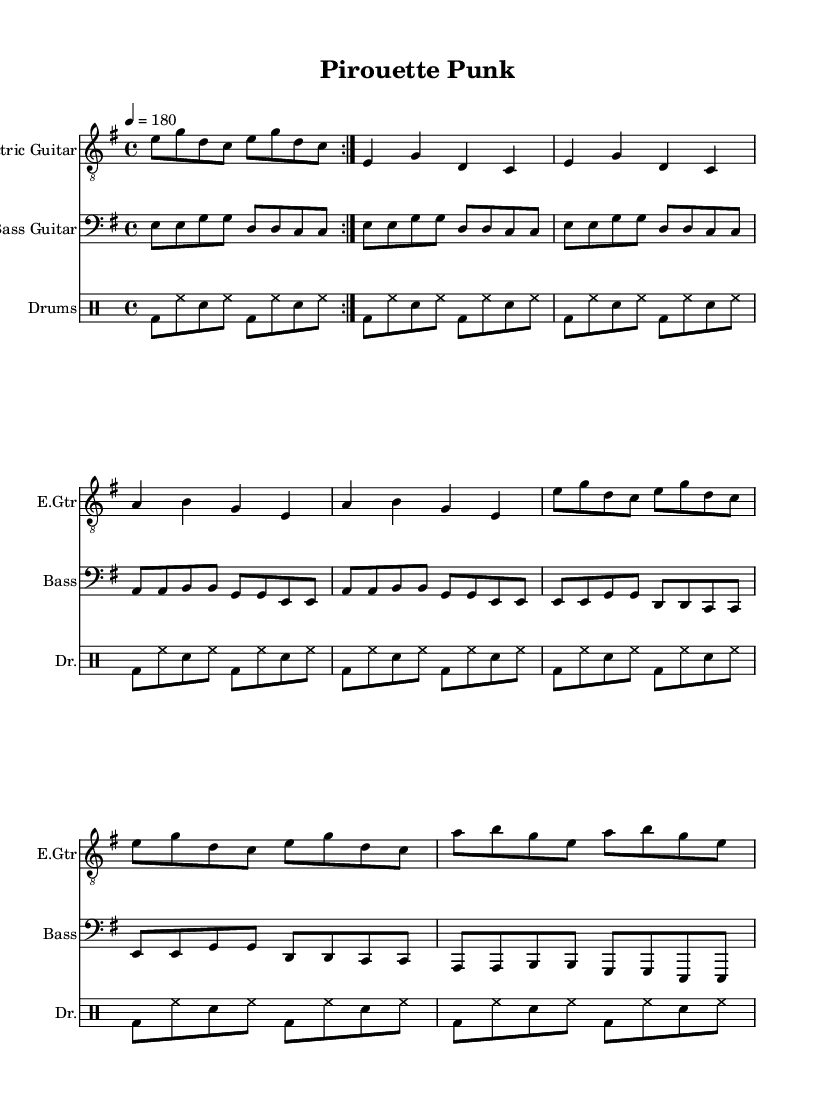What is the key signature of this music? The key signature is indicated at the beginning of the staff. In this case, there is one sharp present, indicating that the key is E minor.
Answer: E minor What is the time signature of the piece? The time signature is found next to the key signature at the beginning. In this sheet music, the time signature shows 4/4, meaning there are four beats in each measure.
Answer: 4/4 What is the tempo marking for this piece? The tempo marking indicates how fast the music should be played and is provided at the start as well. In this case, it states "4 = 180," indicating the beats per minute.
Answer: 180 How many times is the intro repeated? The repeated section is denoted by the "repeat volta" notation before the intro music. Here, it specifies "repeat volta 2," meaning the intro should be played twice.
Answer: 2 What type of music style does this piece represent? The music is characterized by its energetic style, prominent electric guitars, and fast tempo, which aligns it more closely with the punk genre. The fast rhythms and heavy instrumentation highlight its punk qualities.
Answer: Punk What instruments are featured in this score? The instruments can be identified from the headers at the beginning of each staff. This score includes electric guitar, bass guitar, and drums.
Answer: Electric guitar, bass guitar, drums What is the opening note of the electric guitar part? The opening note is found at the beginning of the staff for the electric guitar. In this score, it starts with the note E.
Answer: E 